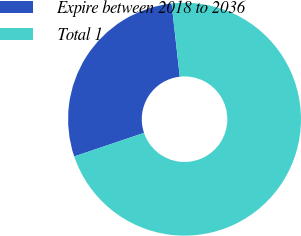Convert chart to OTSL. <chart><loc_0><loc_0><loc_500><loc_500><pie_chart><fcel>Expire between 2018 to 2036<fcel>Total 1<nl><fcel>28.41%<fcel>71.59%<nl></chart> 